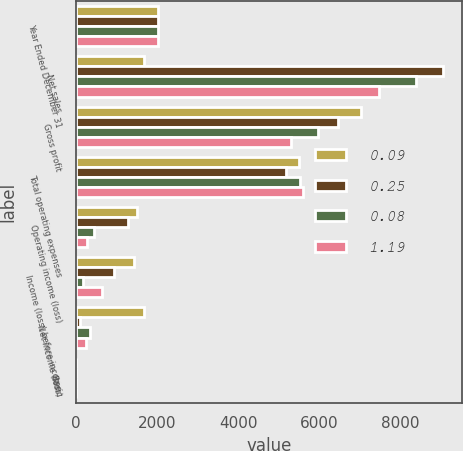Convert chart. <chart><loc_0><loc_0><loc_500><loc_500><stacked_bar_chart><ecel><fcel>Year Ended December 31<fcel>Net sales<fcel>Gross profit<fcel>Total operating expenses<fcel>Operating income (loss)<fcel>Income (loss) before income<fcel>Net income (loss)<fcel>Basic<nl><fcel>0.09<fcel>2018<fcel>1671<fcel>7011<fcel>5504<fcel>1506<fcel>1422<fcel>1671<fcel>1.21<nl><fcel>0.25<fcel>2017<fcel>9048<fcel>6455<fcel>5170<fcel>1285<fcel>933<fcel>104<fcel>0.08<nl><fcel>0.08<fcel>2016<fcel>8386<fcel>5962<fcel>5515<fcel>447<fcel>177<fcel>347<fcel>0.26<nl><fcel>1.19<fcel>2015<fcel>7477<fcel>5304<fcel>5587<fcel>283<fcel>650<fcel>239<fcel>0.18<nl></chart> 